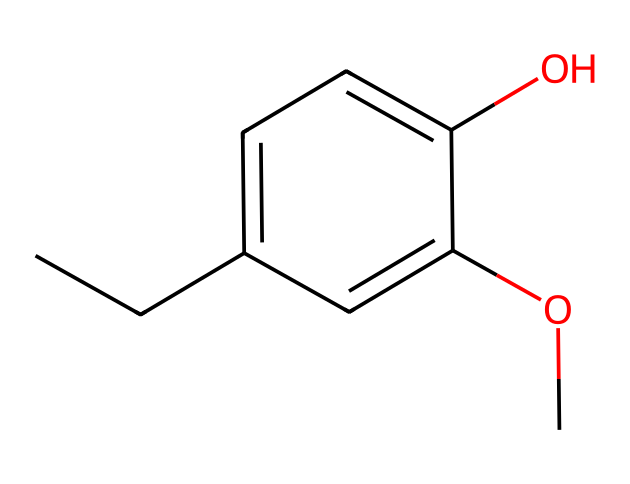What is the molecular formula of eugenol? To find the molecular formula, we count the number of each type of atom in the SMILES representation: C: 10, H: 12, O: 2. Combining these gives the molecular formula C10H12O2.
Answer: C10H12O2 How many hydroxyl (–OH) groups are present in eugenol? In the structure, we identify the –OH group in the phenolic part of the molecule. There is only one hydroxyl group present in eugenol.
Answer: one What is the functional group present in eugenol? The main functional group identifiable in the structure is the phenolic –OH group, which is characteristic of phenols.
Answer: phenolic What type of bond connects the carbon atoms in eugenol? The carbon atoms are primarily connected by single covalent bonds, which is typical in organic compounds, and there is also a double bond inferred in the aromatic ring.
Answer: single and double What is the significance of the methoxy (–OCH3) group in eugenol? The methoxy group contributes to the properties of eugenol, enhancing its solubility and preventing oxidation, which is important for its flavor and therapeutic benefits.
Answer: enhances properties How does the structure of eugenol relate to its use in natural remedies? The phenolic structure provides anti-inflammatory and antiseptic properties, making eugenol effective for soothing throat irritations and other natural remedies.
Answer: anti-inflammatory What is the number of aromatic carbon atoms in eugenol? We identify the aromatic ring consisting of six carbon atoms within the structure, thus confirming that there are six aromatic carbon atoms.
Answer: six 